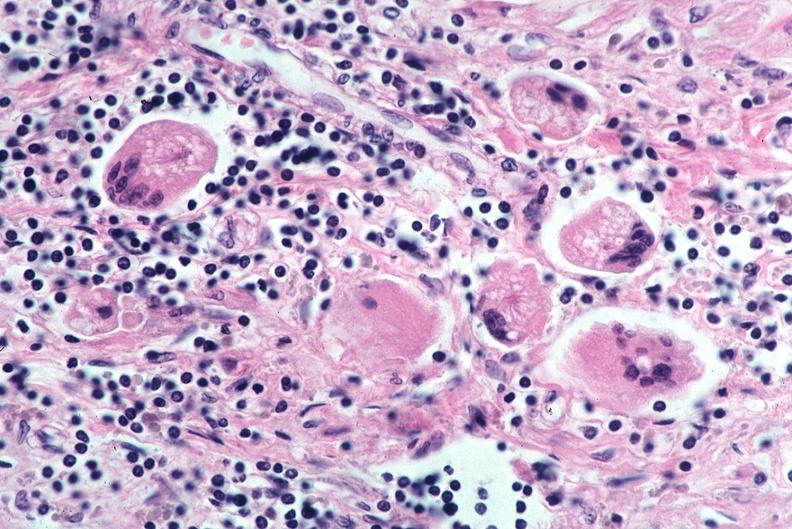where is this?
Answer the question using a single word or phrase. Lung 